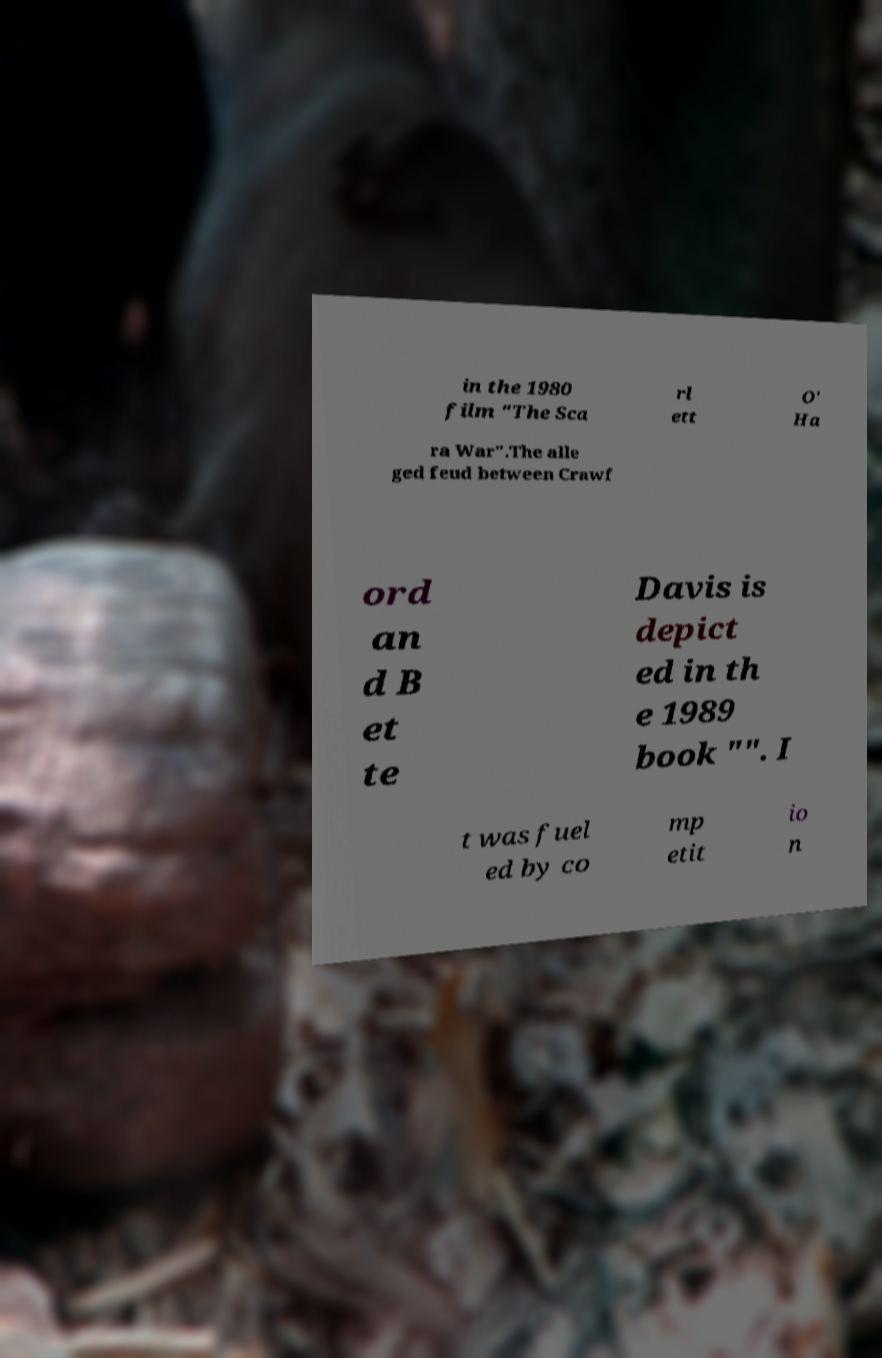Please identify and transcribe the text found in this image. in the 1980 film "The Sca rl ett O' Ha ra War".The alle ged feud between Crawf ord an d B et te Davis is depict ed in th e 1989 book "". I t was fuel ed by co mp etit io n 